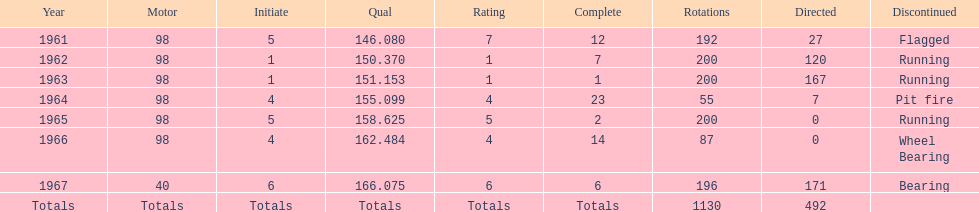What car ranked #1 from 1962-1963? 98. 